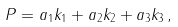<formula> <loc_0><loc_0><loc_500><loc_500>P = a _ { 1 } k _ { 1 } + a _ { 2 } k _ { 2 } + a _ { 3 } k _ { 3 } \, ,</formula> 